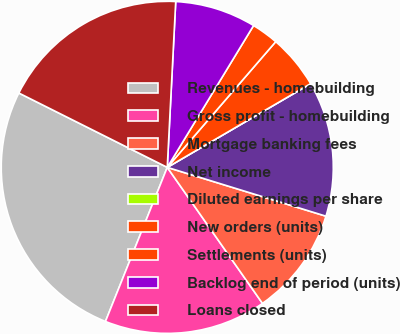Convert chart. <chart><loc_0><loc_0><loc_500><loc_500><pie_chart><fcel>Revenues - homebuilding<fcel>Gross profit - homebuilding<fcel>Mortgage banking fees<fcel>Net income<fcel>Diluted earnings per share<fcel>New orders (units)<fcel>Settlements (units)<fcel>Backlog end of period (units)<fcel>Loans closed<nl><fcel>26.32%<fcel>15.79%<fcel>10.53%<fcel>13.16%<fcel>0.0%<fcel>5.26%<fcel>2.63%<fcel>7.89%<fcel>18.42%<nl></chart> 